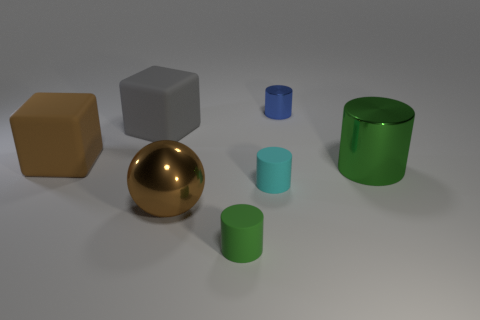Are there more brown blocks to the left of the big gray object than small yellow metallic objects?
Your response must be concise. Yes. Are any large yellow blocks visible?
Offer a terse response. No. How many other things are the same shape as the small green thing?
Make the answer very short. 3. Is the color of the big thing that is in front of the large green cylinder the same as the big matte block that is in front of the large gray matte thing?
Your answer should be very brief. Yes. There is a blue cylinder that is behind the brown object that is behind the large metallic object right of the small blue metallic cylinder; what size is it?
Your answer should be very brief. Small. What shape is the shiny thing that is both in front of the large gray block and behind the brown metallic sphere?
Make the answer very short. Cylinder. Are there an equal number of large brown balls behind the green metallic cylinder and rubber cubes that are in front of the big gray matte object?
Give a very brief answer. No. Are there any green objects that have the same material as the large brown block?
Make the answer very short. Yes. Is the block that is right of the brown cube made of the same material as the big cylinder?
Keep it short and to the point. No. There is a object that is on the right side of the brown shiny object and behind the large brown matte block; how big is it?
Your response must be concise. Small. 